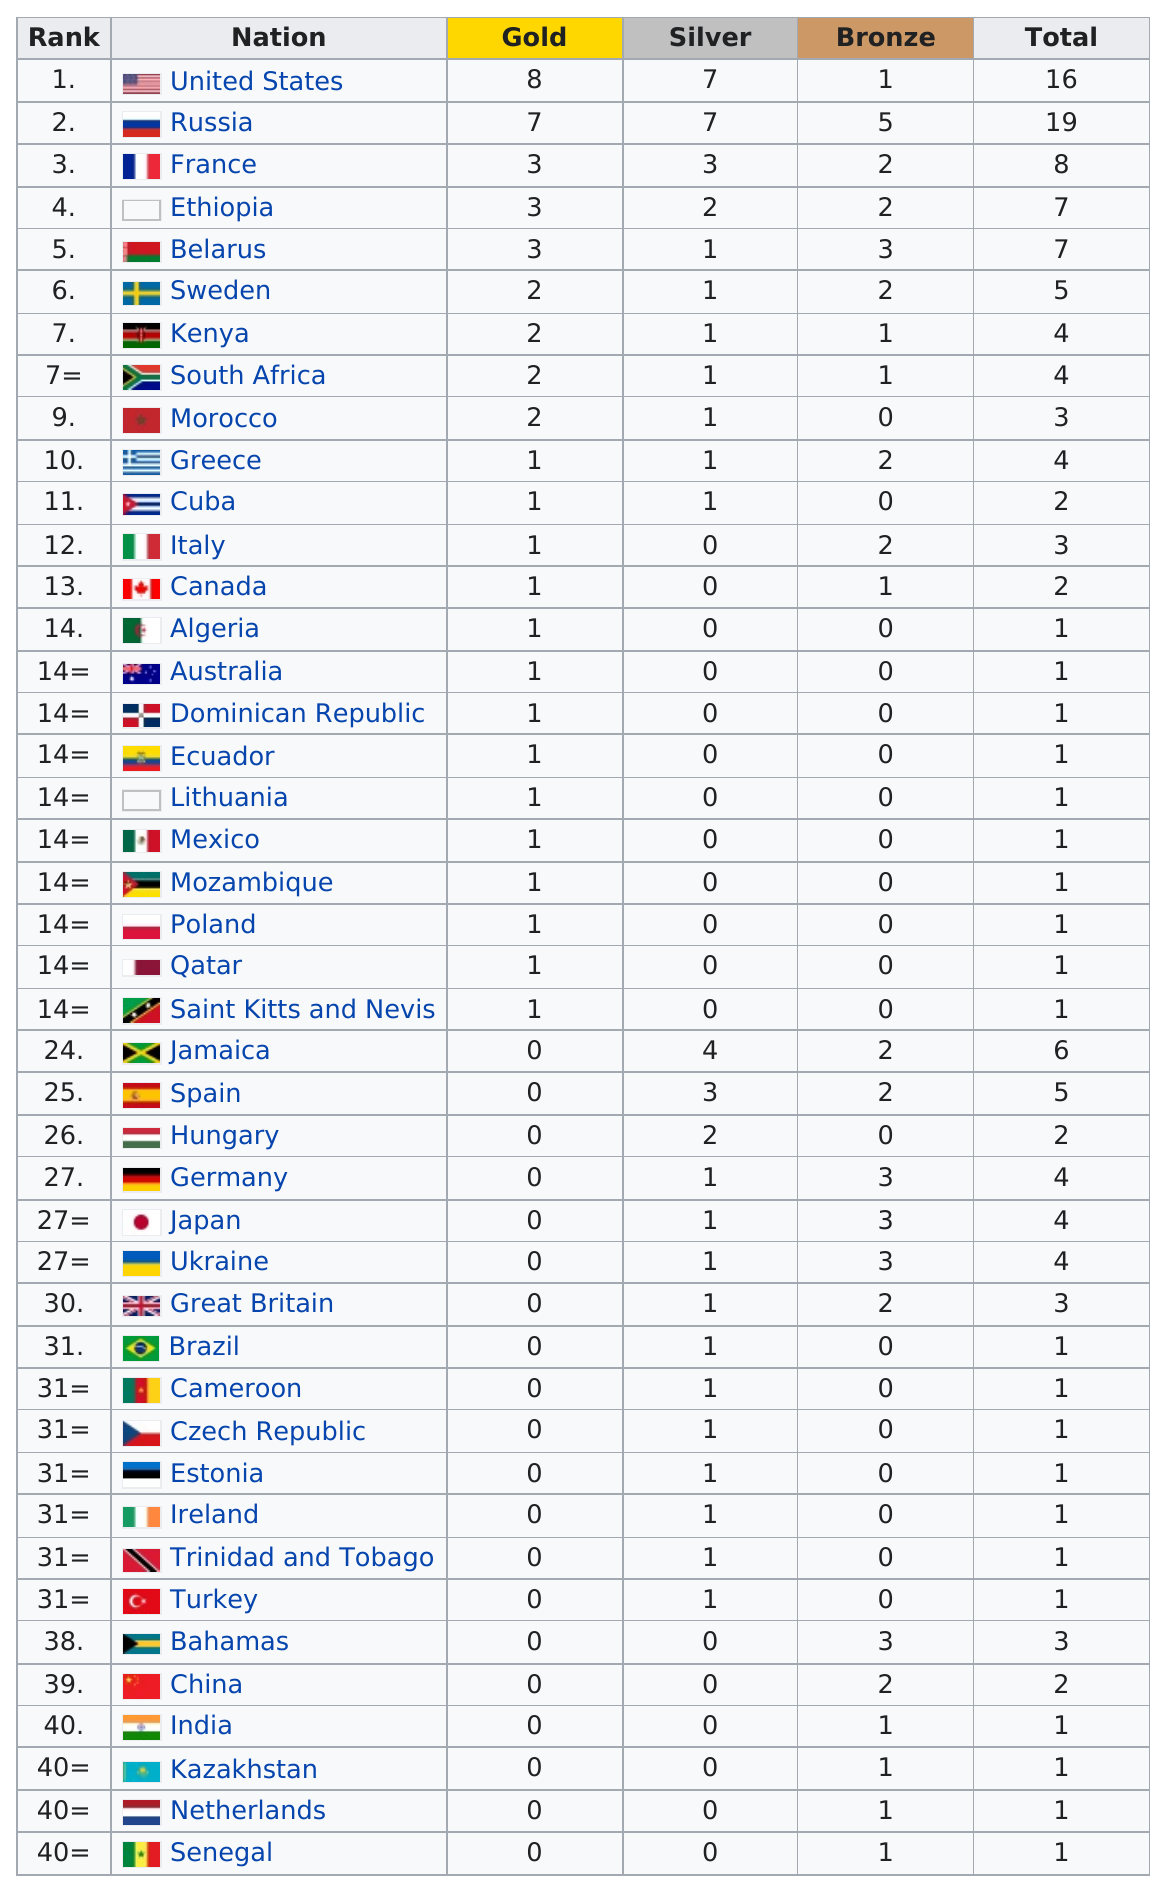Point out several critical features in this image. Russia, a country that has won only 7 gold medals, is known for its lack of success in the Olympic Games. The difference in rank between the United States and Canada was 12. France has won a total of 8 medals. In total, the United States and Russia won 35 medals combined at the 2022 Winter Olympics and Paralympics. The United States won more than 10 medals at the competition. 